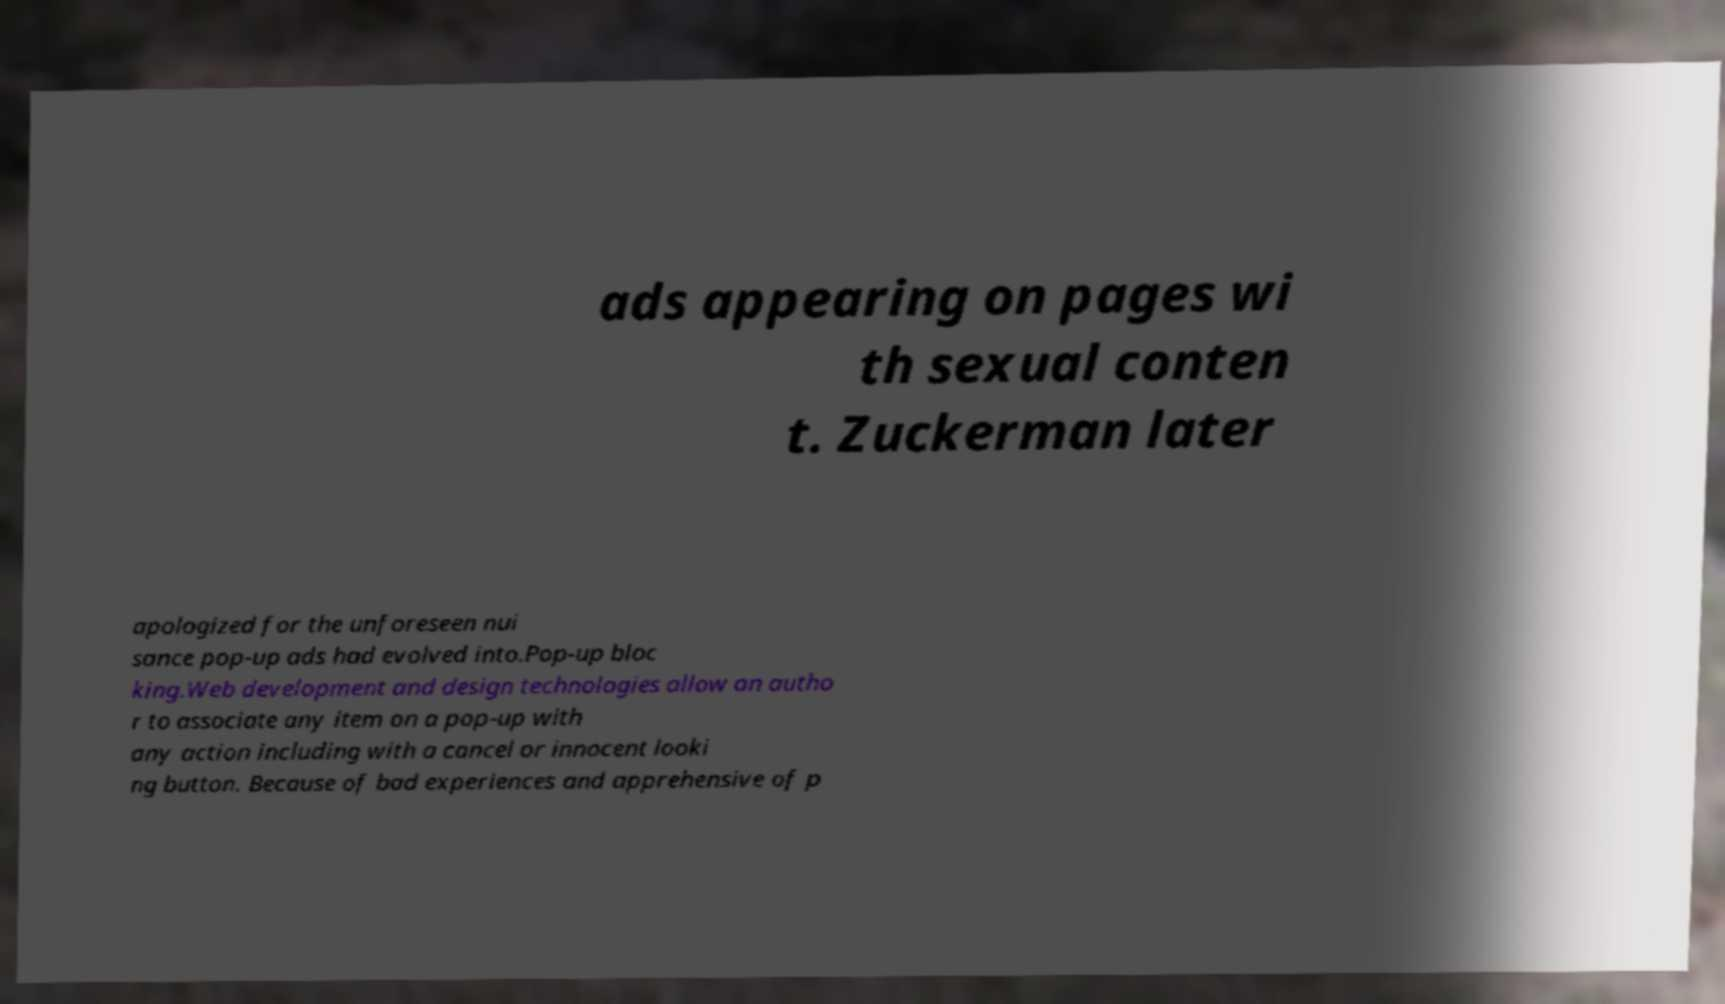Please identify and transcribe the text found in this image. ads appearing on pages wi th sexual conten t. Zuckerman later apologized for the unforeseen nui sance pop-up ads had evolved into.Pop-up bloc king.Web development and design technologies allow an autho r to associate any item on a pop-up with any action including with a cancel or innocent looki ng button. Because of bad experiences and apprehensive of p 